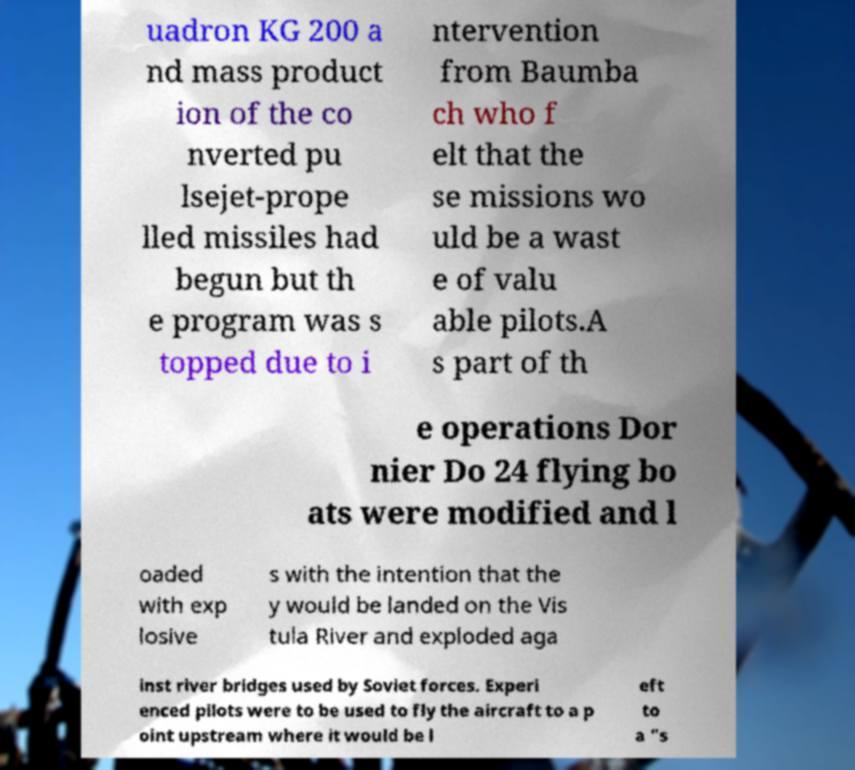I need the written content from this picture converted into text. Can you do that? uadron KG 200 a nd mass product ion of the co nverted pu lsejet-prope lled missiles had begun but th e program was s topped due to i ntervention from Baumba ch who f elt that the se missions wo uld be a wast e of valu able pilots.A s part of th e operations Dor nier Do 24 flying bo ats were modified and l oaded with exp losive s with the intention that the y would be landed on the Vis tula River and exploded aga inst river bridges used by Soviet forces. Experi enced pilots were to be used to fly the aircraft to a p oint upstream where it would be l eft to a "s 